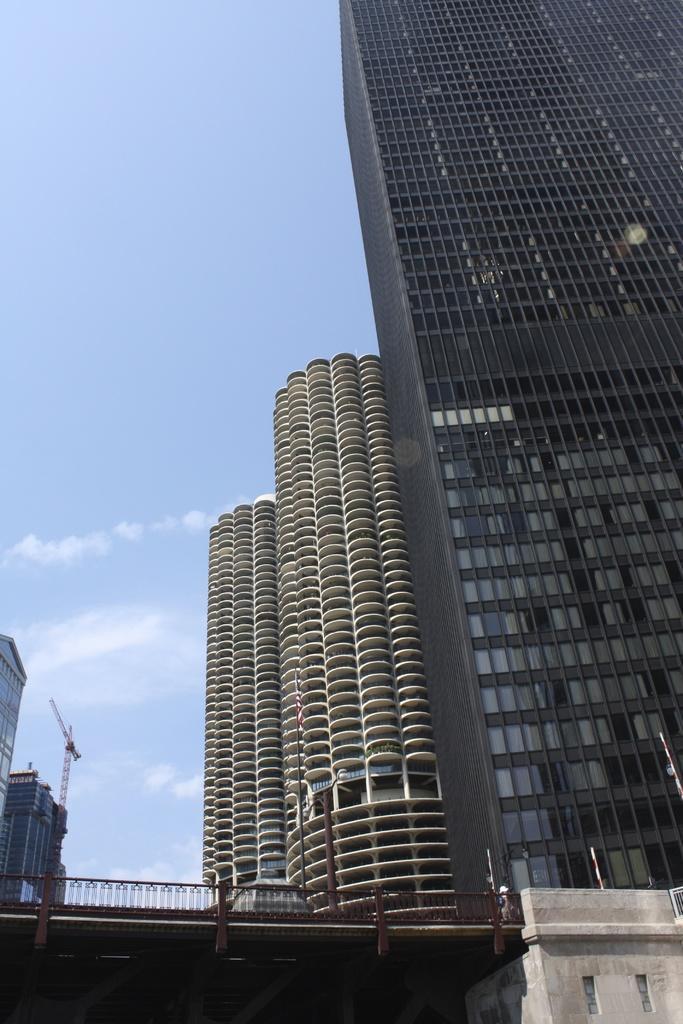Could you give a brief overview of what you see in this image? In this image we can see buildings. There is a bridge. At the top of the image there is sky. 